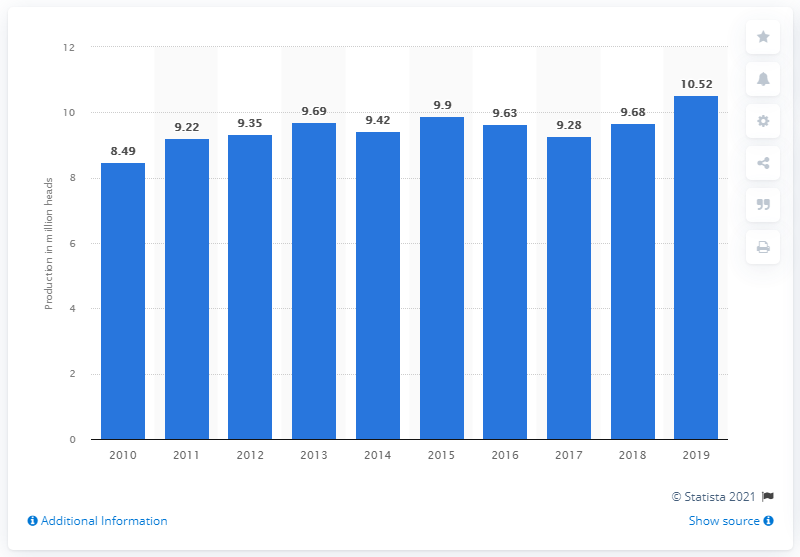Mention a couple of crucial points in this snapshot. In 2019, there was a significant increase in the production of ducks in Malaysia, with an increase of 10.52% compared to the previous year. In 2019, a total of 10,520 ducks were produced in Malaysia. 